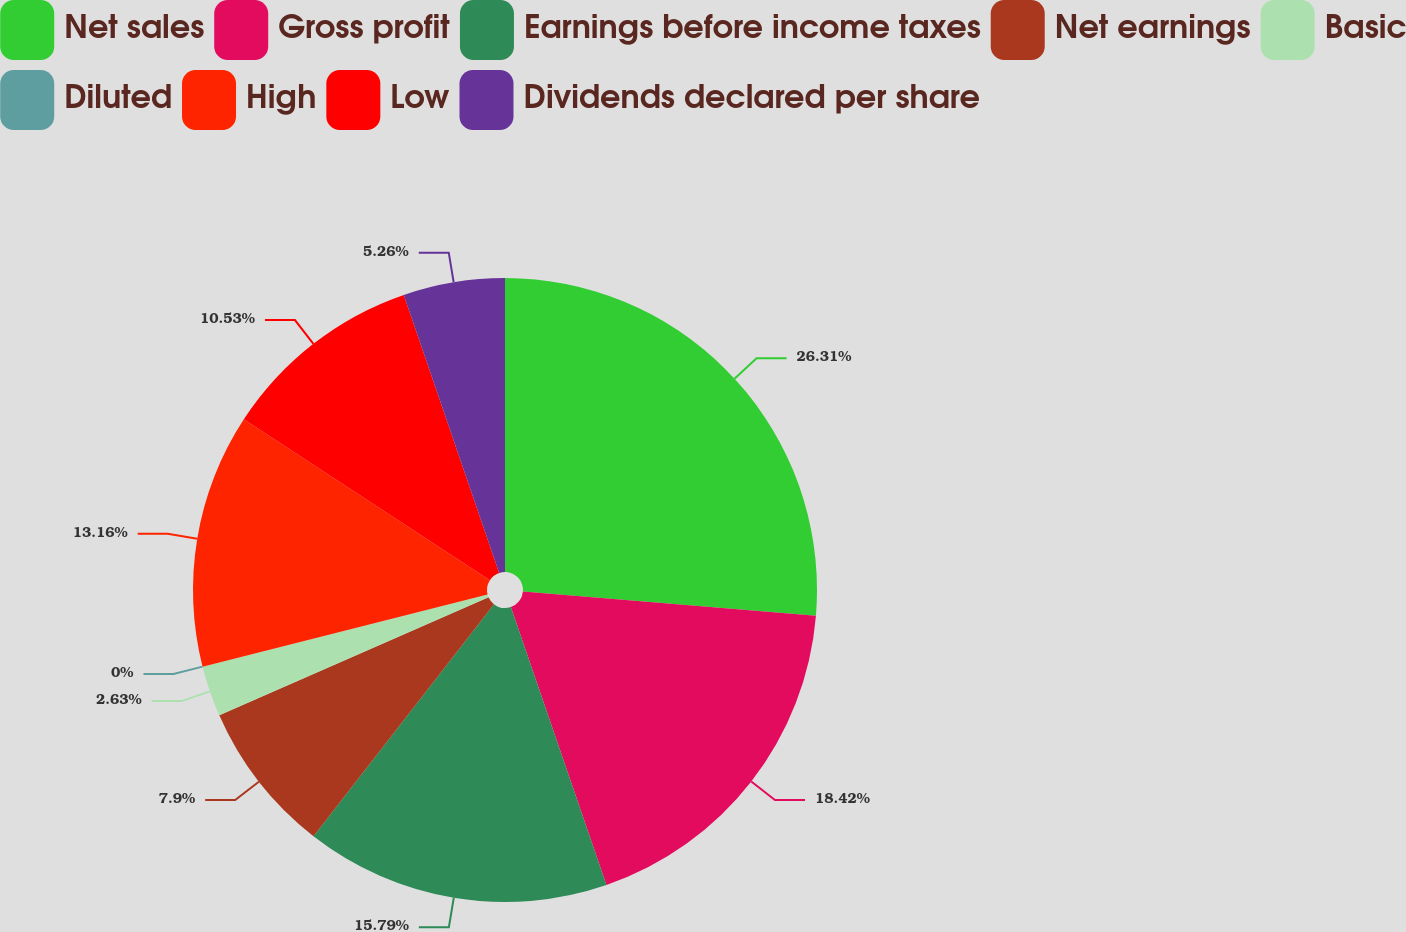Convert chart. <chart><loc_0><loc_0><loc_500><loc_500><pie_chart><fcel>Net sales<fcel>Gross profit<fcel>Earnings before income taxes<fcel>Net earnings<fcel>Basic<fcel>Diluted<fcel>High<fcel>Low<fcel>Dividends declared per share<nl><fcel>26.31%<fcel>18.42%<fcel>15.79%<fcel>7.9%<fcel>2.63%<fcel>0.0%<fcel>13.16%<fcel>10.53%<fcel>5.26%<nl></chart> 